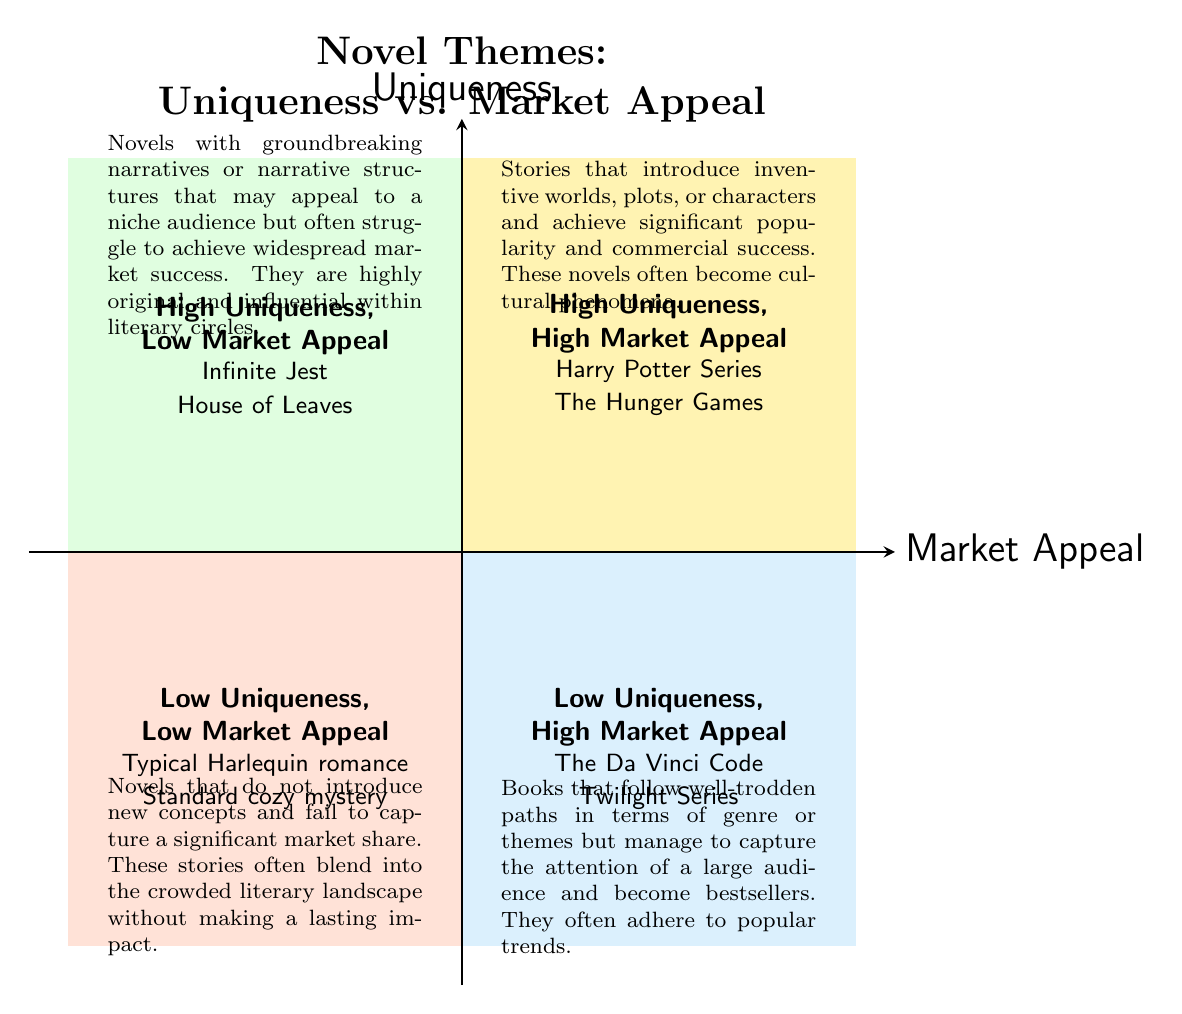What are the titles of examples in the High Uniqueness, High Market Appeal quadrant? The diagram shows that the examples in this quadrant are "Harry Potter Series" and "The Hunger Games." I identified this by reading the label and list of examples provided in that section.
Answer: Harry Potter Series, The Hunger Games How many quadrants are represented in the diagram? The diagram consists of four quadrants, each indicating a different combination of uniqueness and market appeal. I counted the distinct areas visually marked in the chart.
Answer: 4 What type of novels are categorized as High Uniqueness, Low Market Appeal? The diagram specifies that novels like "Infinite Jest" and "House of Leaves" fit into this category, as noted in their respective quadrant description. This information is directly stated in that section of the chart.
Answer: Infinite Jest, House of Leaves What is the description for novels in the Low Uniqueness, High Market Appeal quadrant? The description provided in the diagram indicates that this category includes books that follow well-trodden paths but attract a large audience. I derived this from the text associated with that specific quadrant.
Answer: Books that follow well-trodden paths in terms of genre or themes but manage to capture the attention of a large audience and become bestsellers Which quadrant contains the title "Twilight Series"? "Twilight Series" is clearly indicated within the Low Uniqueness, High Market Appeal quadrant, as shown in the examples listed there. I found this by checking the examples mentioned under that category.
Answer: Low Uniqueness, High Market Appeal How does the description of the High Uniqueness, Low Market Appeal quadrant compare to the description of the Low Uniqueness, Low Market Appeal quadrant? The High Uniqueness, Low Market Appeal quadrant describes revolutionary narratives appealing to a niche audience, while the Low Uniqueness, Low Market Appeal quadrant discusses novels failing to introduce new concepts and lacking significant market share. This comparison requires analyzing the content and intents of both quadrants.
Answer: Groundbreaking vs. non-innovative What is the main characteristic of novels in the Low Uniqueness, Low Market Appeal quadrant? This quadrant describes novels that do not introduce new concepts and fail to capture significant market share, indicating their typicality and lack of impact. I identified this by referring to the description directly under that category.
Answer: Do not introduce new concepts, fail to capture significant market share Which authors are associated with examples in the High Uniqueness, High Market Appeal quadrant? The authors J.K. Rowling and Suzanne Collins are linked to the examples "Harry Potter Series" and "The Hunger Games," respectively, as specified in that section of the diagram.
Answer: J.K. Rowling, Suzanne Collins 